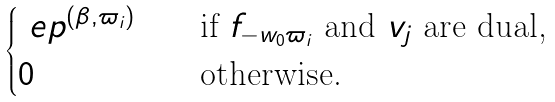<formula> <loc_0><loc_0><loc_500><loc_500>\begin{cases} \ e p ^ { ( \beta , \varpi _ { i } ) } \quad & \text {if $f_{-w_{0}\varpi_{i}}$ and $v_{j}$ are dual,} \\ 0 & \text {otherwise.} \end{cases}</formula> 